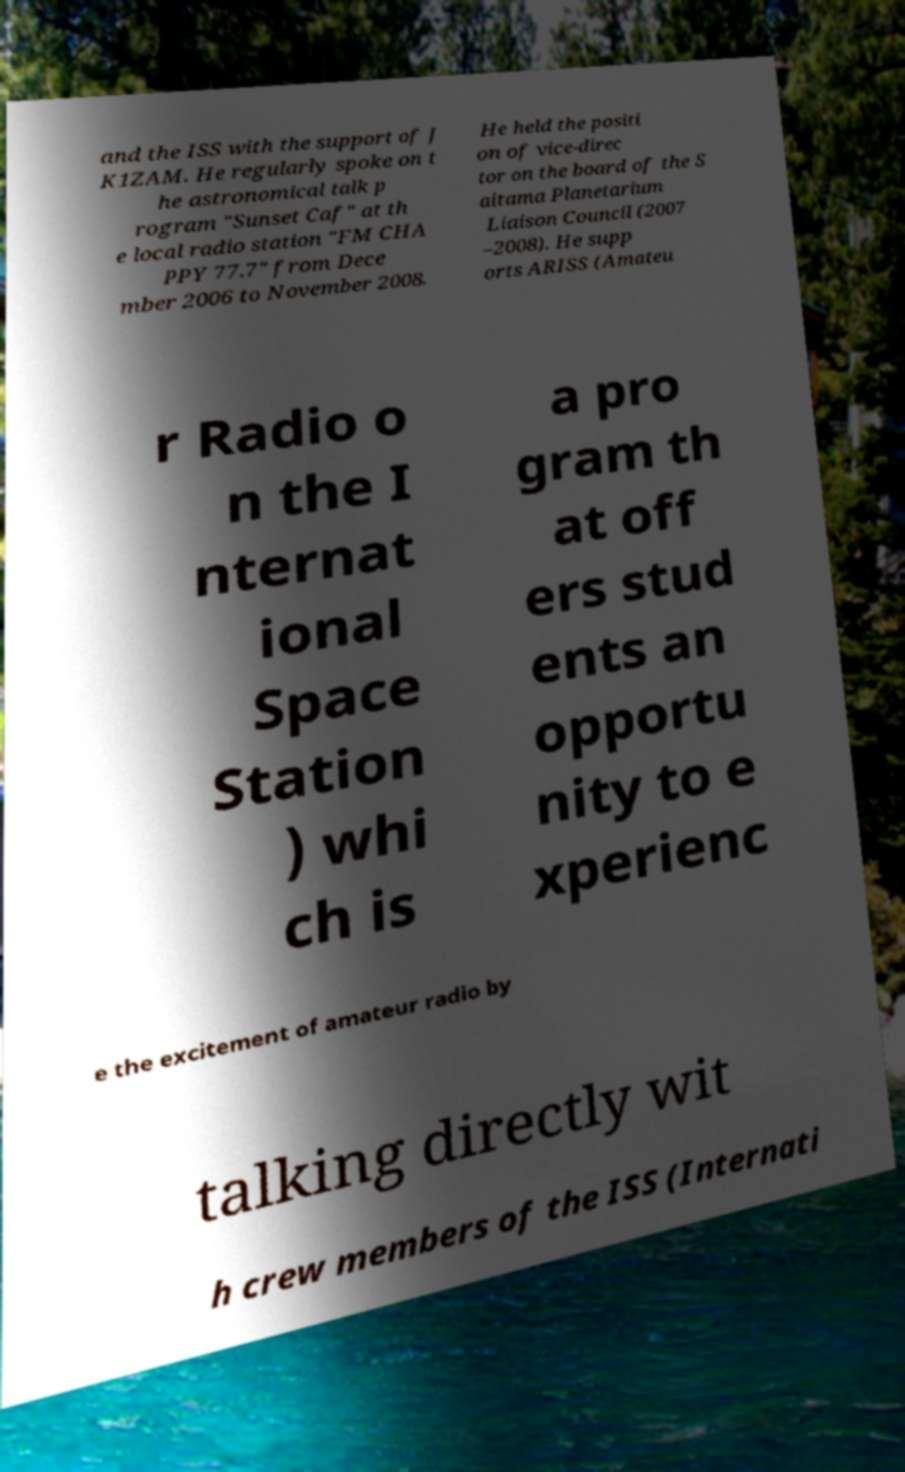What messages or text are displayed in this image? I need them in a readable, typed format. and the ISS with the support of J K1ZAM. He regularly spoke on t he astronomical talk p rogram "Sunset Caf" at th e local radio station "FM CHA PPY 77.7" from Dece mber 2006 to November 2008. He held the positi on of vice-direc tor on the board of the S aitama Planetarium Liaison Council (2007 –2008). He supp orts ARISS (Amateu r Radio o n the I nternat ional Space Station ) whi ch is a pro gram th at off ers stud ents an opportu nity to e xperienc e the excitement of amateur radio by talking directly wit h crew members of the ISS (Internati 